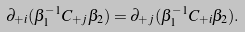<formula> <loc_0><loc_0><loc_500><loc_500>\partial _ { + i } ( \beta _ { 1 } ^ { - 1 } C _ { + j } \beta _ { 2 } ) = \partial _ { + j } ( \beta _ { 1 } ^ { - 1 } C _ { + i } \beta _ { 2 } ) .</formula> 